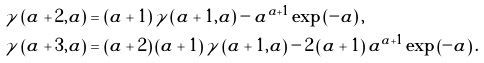Convert formula to latex. <formula><loc_0><loc_0><loc_500><loc_500>\gamma \left ( a + 2 , a \right ) & = \left ( a + 1 \right ) \gamma \left ( a + 1 , a \right ) - a ^ { a + 1 } \exp \left ( - a \right ) , \\ \gamma \left ( a + 3 , a \right ) & = \left ( a + 2 \right ) \left ( a + 1 \right ) \gamma \left ( a + 1 , a \right ) - 2 \left ( a + 1 \right ) a ^ { a + 1 } \exp \left ( - a \right ) .</formula> 